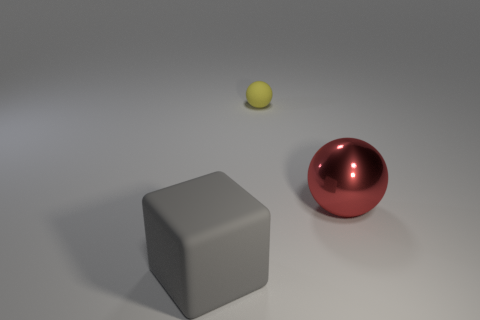There is a big object to the left of the sphere behind the red shiny ball; what is its material?
Your answer should be very brief. Rubber. How big is the rubber thing on the left side of the object that is behind the sphere that is on the right side of the small yellow rubber sphere?
Provide a succinct answer. Large. What number of brown balls are the same material as the yellow ball?
Offer a terse response. 0. What color is the large thing that is behind the rubber thing that is in front of the small yellow sphere?
Your response must be concise. Red. What number of things are either red spheres or objects in front of the small yellow matte ball?
Ensure brevity in your answer.  2. Is there a matte thing of the same color as the metal thing?
Give a very brief answer. No. How many cyan things are big metal objects or big rubber cubes?
Keep it short and to the point. 0. What number of other objects are there of the same size as the red object?
Offer a terse response. 1. How many big things are red things or objects?
Offer a terse response. 2. Does the red thing have the same size as the thing in front of the large red thing?
Provide a succinct answer. Yes. 